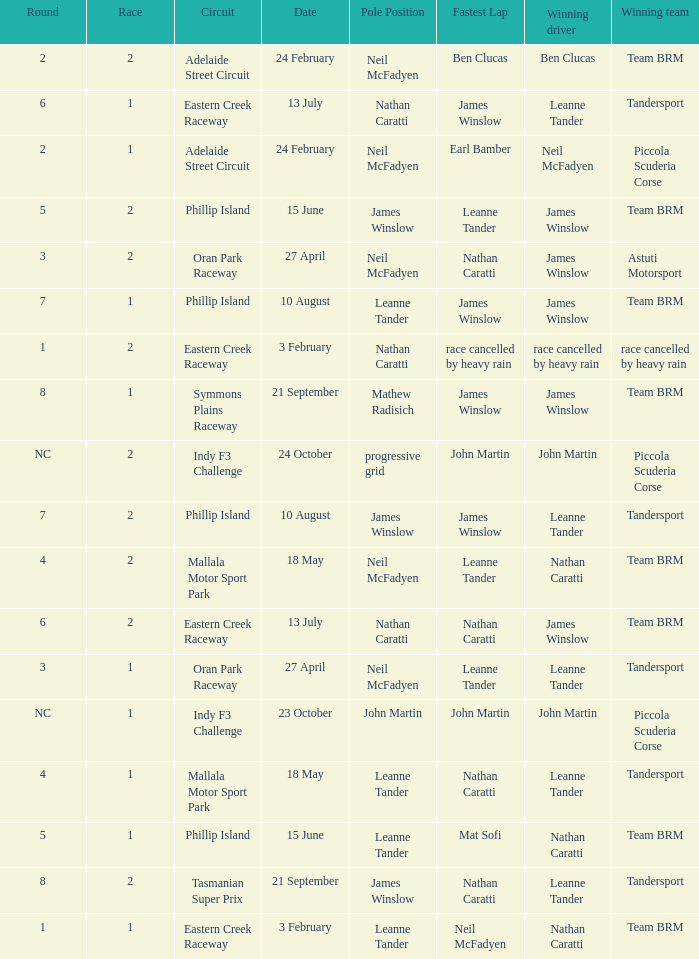What is the highest race number in the Phillip Island circuit with James Winslow as the winning driver and pole position? 2.0. Would you be able to parse every entry in this table? {'header': ['Round', 'Race', 'Circuit', 'Date', 'Pole Position', 'Fastest Lap', 'Winning driver', 'Winning team'], 'rows': [['2', '2', 'Adelaide Street Circuit', '24 February', 'Neil McFadyen', 'Ben Clucas', 'Ben Clucas', 'Team BRM'], ['6', '1', 'Eastern Creek Raceway', '13 July', 'Nathan Caratti', 'James Winslow', 'Leanne Tander', 'Tandersport'], ['2', '1', 'Adelaide Street Circuit', '24 February', 'Neil McFadyen', 'Earl Bamber', 'Neil McFadyen', 'Piccola Scuderia Corse'], ['5', '2', 'Phillip Island', '15 June', 'James Winslow', 'Leanne Tander', 'James Winslow', 'Team BRM'], ['3', '2', 'Oran Park Raceway', '27 April', 'Neil McFadyen', 'Nathan Caratti', 'James Winslow', 'Astuti Motorsport'], ['7', '1', 'Phillip Island', '10 August', 'Leanne Tander', 'James Winslow', 'James Winslow', 'Team BRM'], ['1', '2', 'Eastern Creek Raceway', '3 February', 'Nathan Caratti', 'race cancelled by heavy rain', 'race cancelled by heavy rain', 'race cancelled by heavy rain'], ['8', '1', 'Symmons Plains Raceway', '21 September', 'Mathew Radisich', 'James Winslow', 'James Winslow', 'Team BRM'], ['NC', '2', 'Indy F3 Challenge', '24 October', 'progressive grid', 'John Martin', 'John Martin', 'Piccola Scuderia Corse'], ['7', '2', 'Phillip Island', '10 August', 'James Winslow', 'James Winslow', 'Leanne Tander', 'Tandersport'], ['4', '2', 'Mallala Motor Sport Park', '18 May', 'Neil McFadyen', 'Leanne Tander', 'Nathan Caratti', 'Team BRM'], ['6', '2', 'Eastern Creek Raceway', '13 July', 'Nathan Caratti', 'Nathan Caratti', 'James Winslow', 'Team BRM'], ['3', '1', 'Oran Park Raceway', '27 April', 'Neil McFadyen', 'Leanne Tander', 'Leanne Tander', 'Tandersport'], ['NC', '1', 'Indy F3 Challenge', '23 October', 'John Martin', 'John Martin', 'John Martin', 'Piccola Scuderia Corse'], ['4', '1', 'Mallala Motor Sport Park', '18 May', 'Leanne Tander', 'Nathan Caratti', 'Leanne Tander', 'Tandersport'], ['5', '1', 'Phillip Island', '15 June', 'Leanne Tander', 'Mat Sofi', 'Nathan Caratti', 'Team BRM'], ['8', '2', 'Tasmanian Super Prix', '21 September', 'James Winslow', 'Nathan Caratti', 'Leanne Tander', 'Tandersport'], ['1', '1', 'Eastern Creek Raceway', '3 February', 'Leanne Tander', 'Neil McFadyen', 'Nathan Caratti', 'Team BRM']]} 